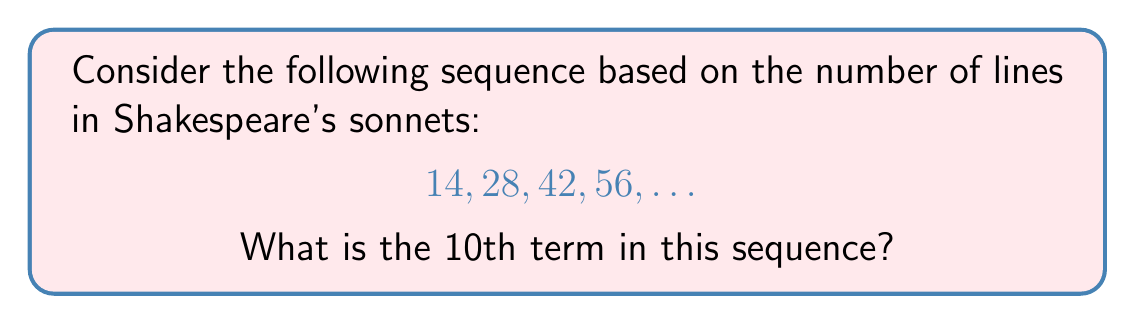Provide a solution to this math problem. To solve this problem, let's approach it step-by-step:

1) First, we need to recognize the pattern in the given sequence. Each term represents a multiple of 14, which is the number of lines in a Shakespearean sonnet.

2) We can express this sequence mathematically as:

   $a_n = 14n$, where $n$ is the position of the term in the sequence.

3) Let's verify this for the given terms:
   - For $n=1$: $a_1 = 14 \cdot 1 = 14$
   - For $n=2$: $a_2 = 14 \cdot 2 = 28$
   - For $n=3$: $a_3 = 14 \cdot 3 = 42$
   - For $n=4$: $a_4 = 14 \cdot 4 = 56$

4) Now that we've confirmed the pattern, we can find the 10th term by plugging $n=10$ into our formula:

   $a_{10} = 14 \cdot 10 = 140$

Therefore, the 10th term in the sequence is 140.
Answer: 140 